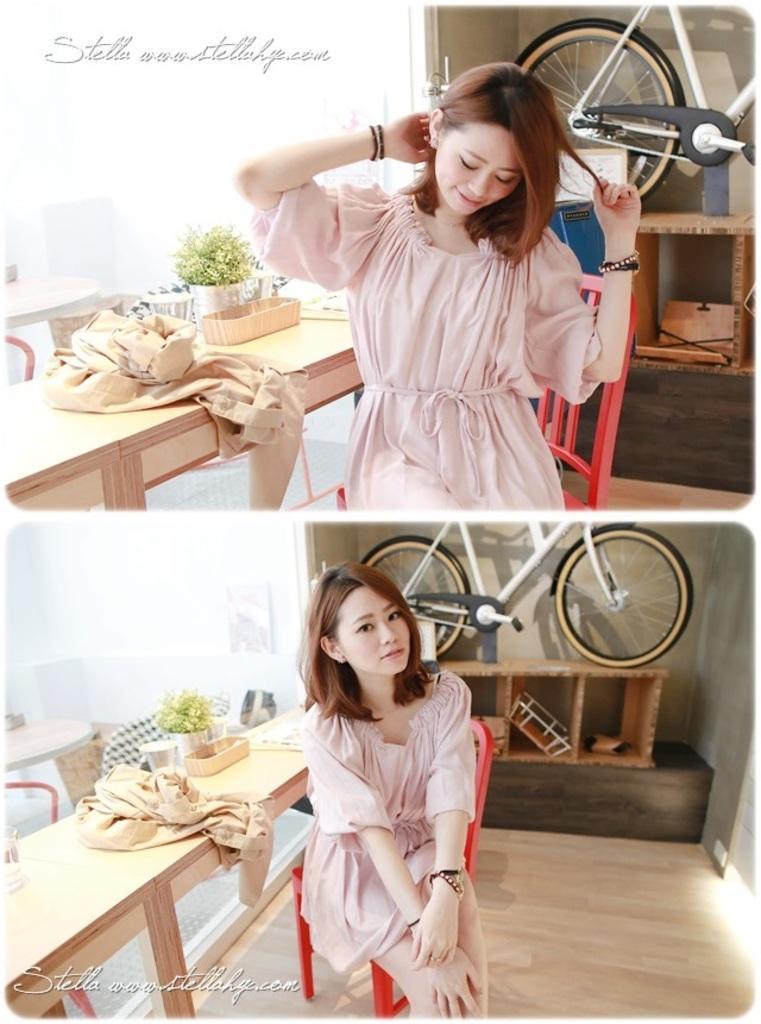In one or two sentences, can you explain what this image depicts? This picture is an edited image and the first part of the image, we see women wearing pink dress. She is sitting on the chair. Beside her, we see table on which flower tree pot is, plant is placed on it. Behind her, we see bicycle and the bottom part of the picture we see the woman sitting on the chair and on the table we find cloth and behind that, we see a wall which is white in color. 